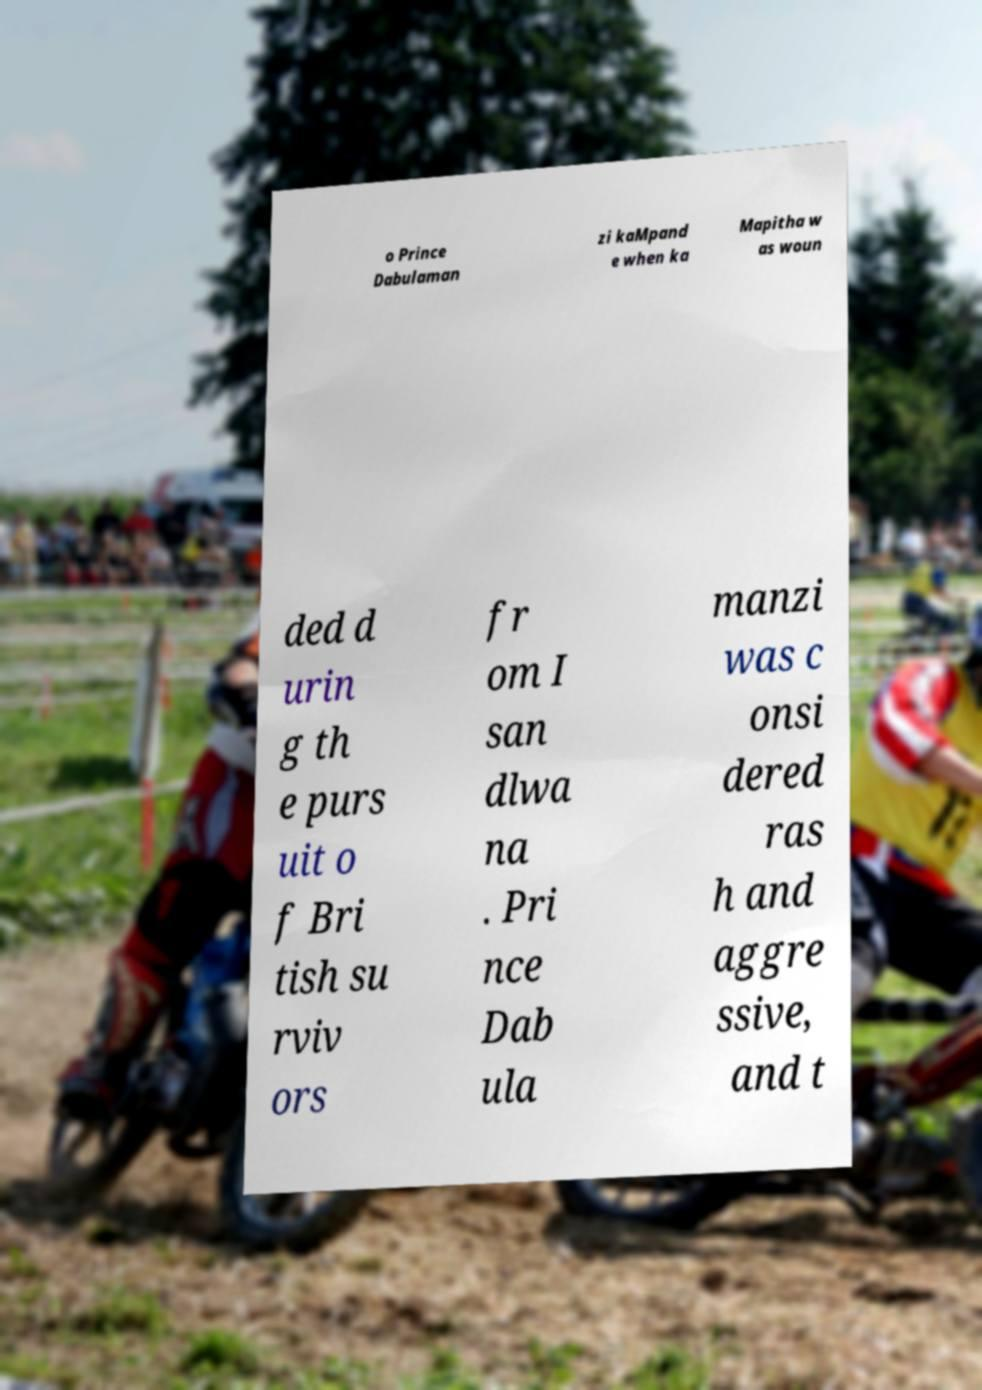For documentation purposes, I need the text within this image transcribed. Could you provide that? o Prince Dabulaman zi kaMpand e when ka Mapitha w as woun ded d urin g th e purs uit o f Bri tish su rviv ors fr om I san dlwa na . Pri nce Dab ula manzi was c onsi dered ras h and aggre ssive, and t 